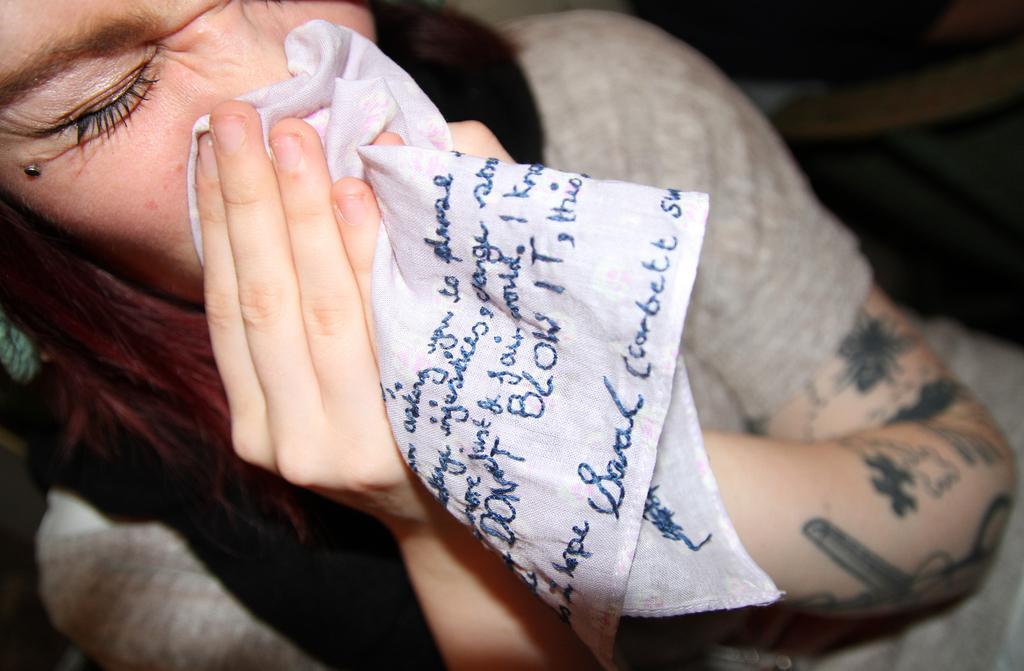Who is the main subject in the image? There is a woman in the image. What is the woman doing in the image? The woman is sitting on a chair and cleaning her nose with a kerchief. What is the color of the woman's hair? The woman has brown hair. What is the woman's reaction to the alarm in the image? There is no alarm present in the image, so it is not possible to determine the woman's reaction to it. 